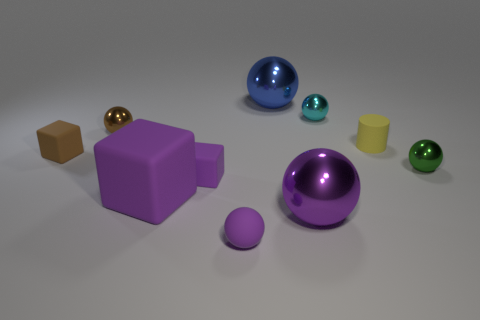Subtract all brown balls. How many balls are left? 5 Subtract all large blue spheres. How many spheres are left? 5 Subtract all gray cubes. Subtract all gray spheres. How many cubes are left? 3 Subtract all cubes. How many objects are left? 7 Subtract 2 purple spheres. How many objects are left? 8 Subtract all objects. Subtract all yellow shiny things. How many objects are left? 0 Add 3 green metal spheres. How many green metal spheres are left? 4 Add 3 spheres. How many spheres exist? 9 